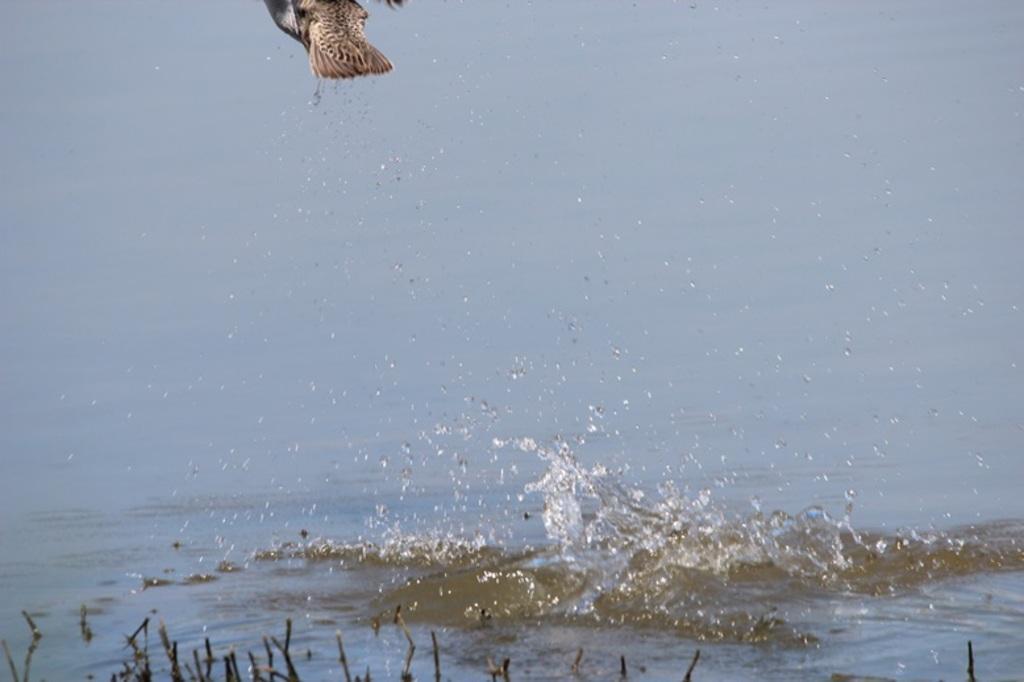How would you summarize this image in a sentence or two? In this picture, we can see a bird in air, water, and some objects in the bottom side of the picture. 